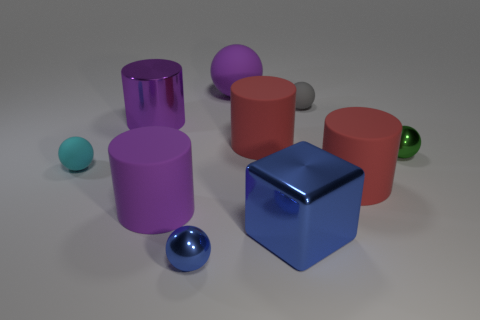Is the number of large red rubber things that are on the right side of the small gray rubber sphere less than the number of tiny cyan rubber things?
Keep it short and to the point. No. What number of metal things are large blue things or big purple balls?
Your response must be concise. 1. Does the metal cylinder have the same color as the large ball?
Your response must be concise. Yes. There is a metallic thing that is behind the small green metal object; does it have the same shape as the tiny object on the right side of the gray ball?
Give a very brief answer. No. How many things are red cylinders or big purple rubber things behind the tiny cyan matte sphere?
Your response must be concise. 3. How many other things are there of the same size as the metallic block?
Offer a terse response. 5. Does the object left of the large purple metallic object have the same material as the purple cylinder that is behind the tiny green metallic sphere?
Offer a very short reply. No. How many cyan rubber objects are on the right side of the big purple shiny object?
Keep it short and to the point. 0. What number of red things are either metallic things or big rubber objects?
Give a very brief answer. 2. There is a green object that is the same size as the cyan ball; what material is it?
Your response must be concise. Metal. 